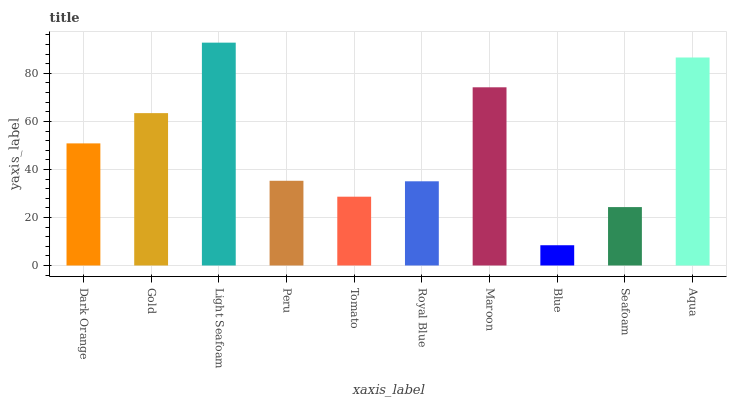Is Blue the minimum?
Answer yes or no. Yes. Is Light Seafoam the maximum?
Answer yes or no. Yes. Is Gold the minimum?
Answer yes or no. No. Is Gold the maximum?
Answer yes or no. No. Is Gold greater than Dark Orange?
Answer yes or no. Yes. Is Dark Orange less than Gold?
Answer yes or no. Yes. Is Dark Orange greater than Gold?
Answer yes or no. No. Is Gold less than Dark Orange?
Answer yes or no. No. Is Dark Orange the high median?
Answer yes or no. Yes. Is Peru the low median?
Answer yes or no. Yes. Is Seafoam the high median?
Answer yes or no. No. Is Blue the low median?
Answer yes or no. No. 